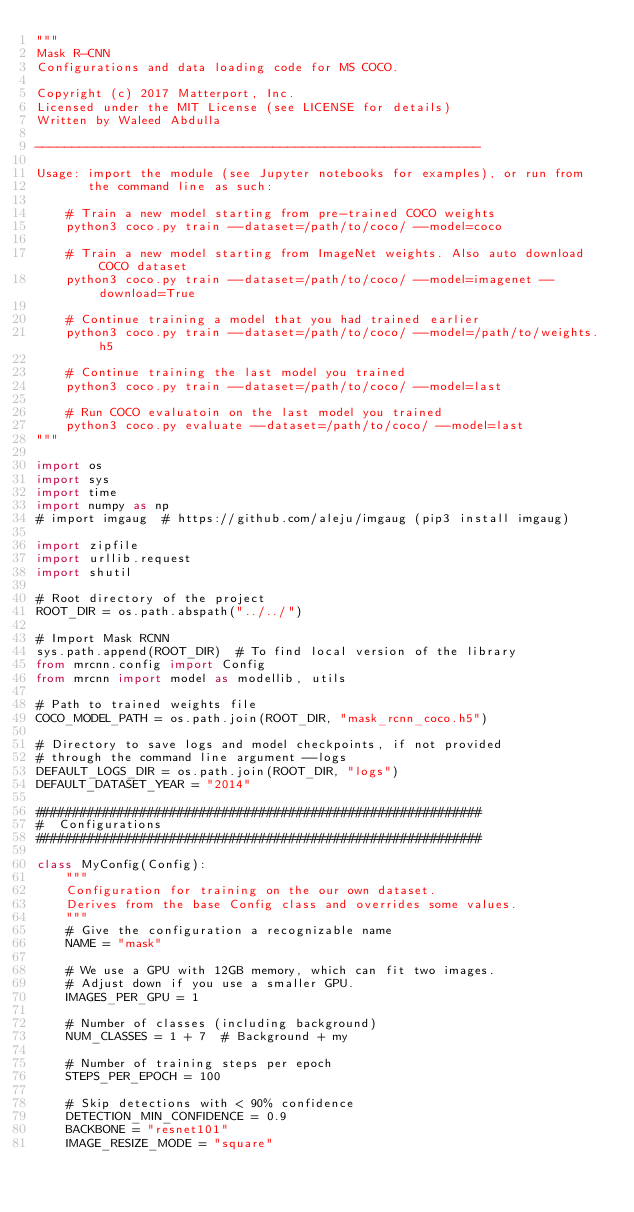<code> <loc_0><loc_0><loc_500><loc_500><_Python_>"""
Mask R-CNN
Configurations and data loading code for MS COCO.

Copyright (c) 2017 Matterport, Inc.
Licensed under the MIT License (see LICENSE for details)
Written by Waleed Abdulla

------------------------------------------------------------

Usage: import the module (see Jupyter notebooks for examples), or run from
       the command line as such:

    # Train a new model starting from pre-trained COCO weights
    python3 coco.py train --dataset=/path/to/coco/ --model=coco

    # Train a new model starting from ImageNet weights. Also auto download COCO dataset
    python3 coco.py train --dataset=/path/to/coco/ --model=imagenet --download=True

    # Continue training a model that you had trained earlier
    python3 coco.py train --dataset=/path/to/coco/ --model=/path/to/weights.h5

    # Continue training the last model you trained
    python3 coco.py train --dataset=/path/to/coco/ --model=last

    # Run COCO evaluatoin on the last model you trained
    python3 coco.py evaluate --dataset=/path/to/coco/ --model=last
"""

import os
import sys
import time
import numpy as np
# import imgaug  # https://github.com/aleju/imgaug (pip3 install imgaug)

import zipfile
import urllib.request
import shutil

# Root directory of the project
ROOT_DIR = os.path.abspath("../../")

# Import Mask RCNN
sys.path.append(ROOT_DIR)  # To find local version of the library
from mrcnn.config import Config
from mrcnn import model as modellib, utils

# Path to trained weights file
COCO_MODEL_PATH = os.path.join(ROOT_DIR, "mask_rcnn_coco.h5")

# Directory to save logs and model checkpoints, if not provided
# through the command line argument --logs
DEFAULT_LOGS_DIR = os.path.join(ROOT_DIR, "logs")
DEFAULT_DATASET_YEAR = "2014"

############################################################
#  Configurations
############################################################

class MyConfig(Config):
    """
    Configuration for training on the our own dataset.
    Derives from the base Config class and overrides some values.
    """
    # Give the configuration a recognizable name
    NAME = "mask"

    # We use a GPU with 12GB memory, which can fit two images.
    # Adjust down if you use a smaller GPU.
    IMAGES_PER_GPU = 1

    # Number of classes (including background)
    NUM_CLASSES = 1 + 7  # Background + my

    # Number of training steps per epoch
    STEPS_PER_EPOCH = 100

    # Skip detections with < 90% confidence
    DETECTION_MIN_CONFIDENCE = 0.9
    BACKBONE = "resnet101"
    IMAGE_RESIZE_MODE = "square"</code> 